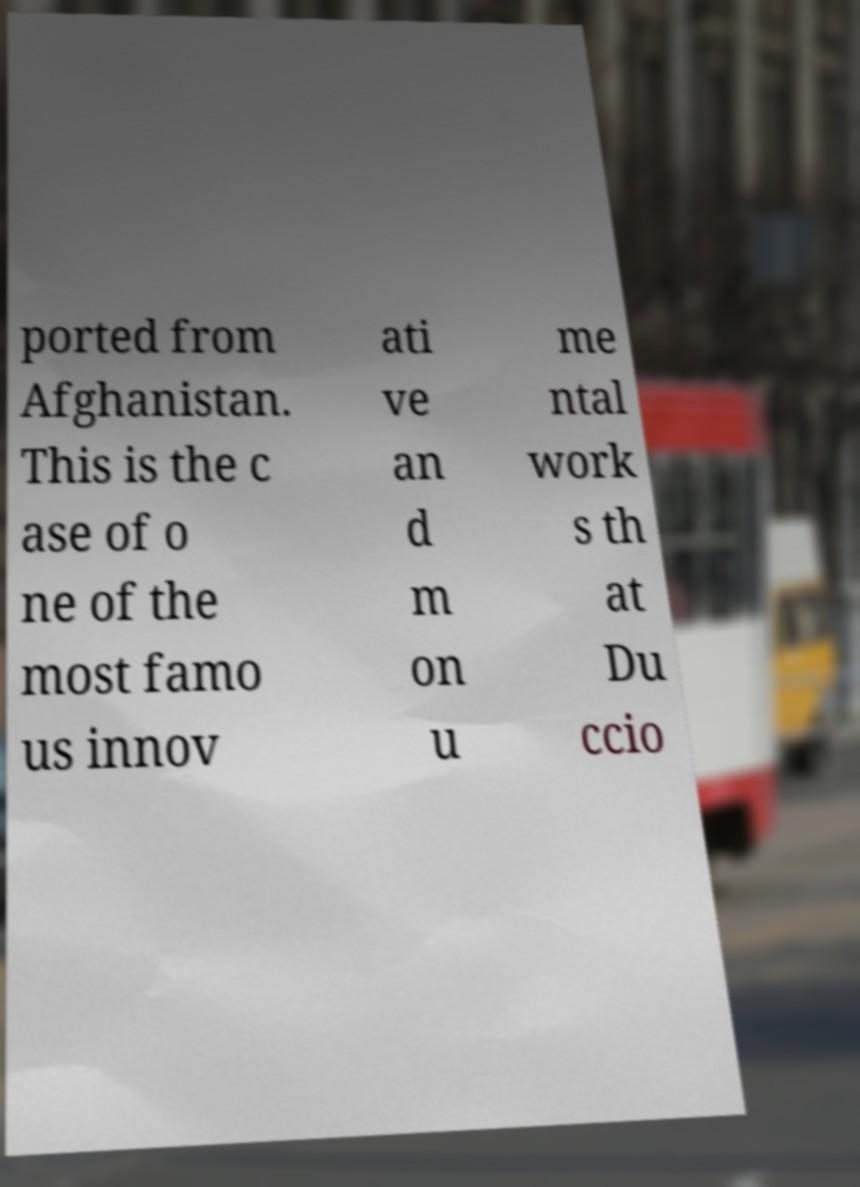Could you assist in decoding the text presented in this image and type it out clearly? ported from Afghanistan. This is the c ase of o ne of the most famo us innov ati ve an d m on u me ntal work s th at Du ccio 